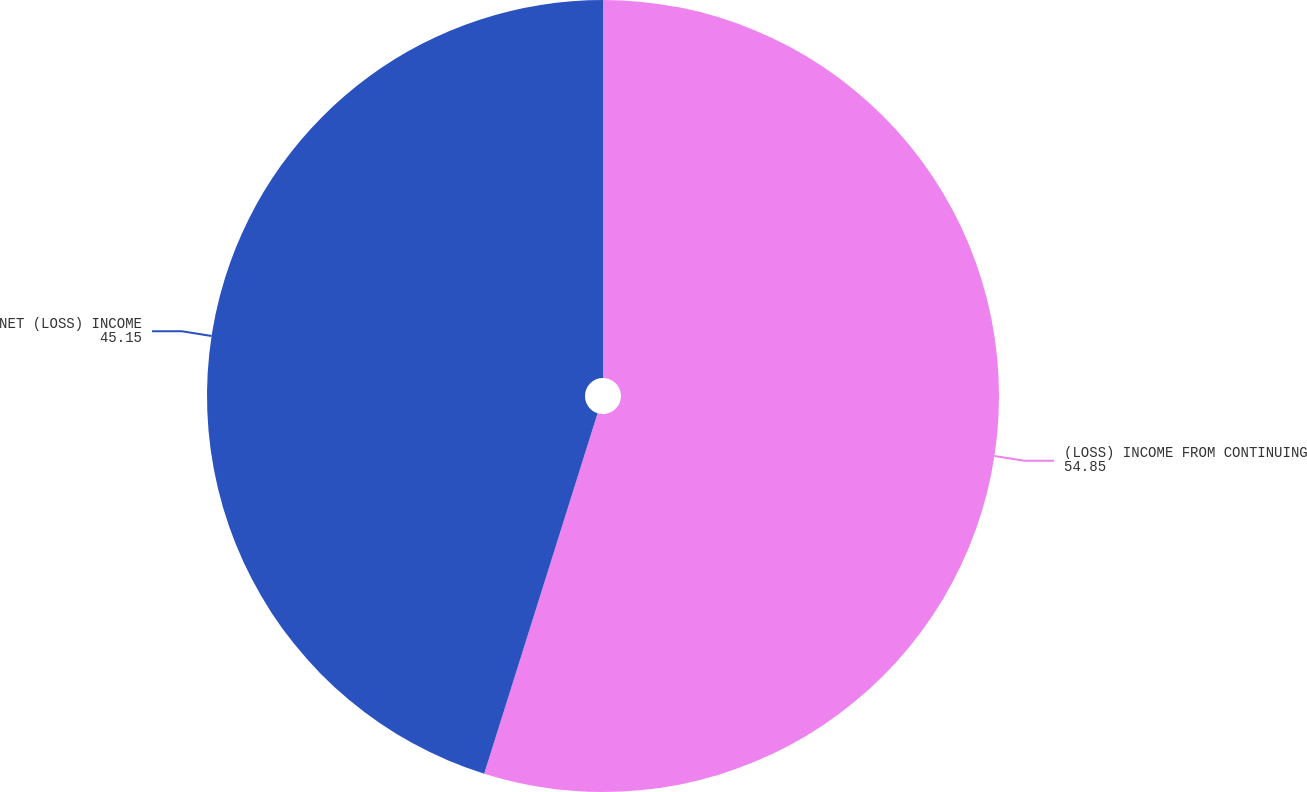Convert chart to OTSL. <chart><loc_0><loc_0><loc_500><loc_500><pie_chart><fcel>(LOSS) INCOME FROM CONTINUING<fcel>NET (LOSS) INCOME<nl><fcel>54.85%<fcel>45.15%<nl></chart> 